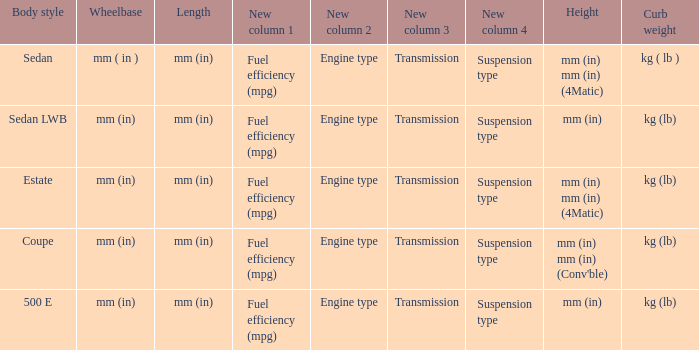What's the length of the model with 500 E body style? Mm (in). 